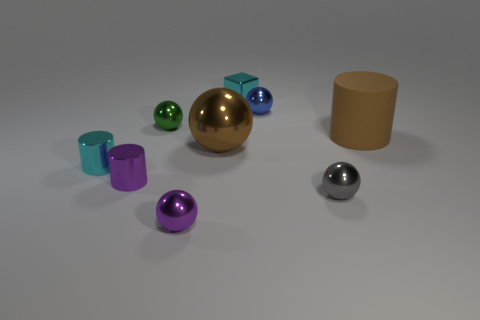Subtract all purple balls. How many balls are left? 4 Subtract 1 spheres. How many spheres are left? 4 Subtract all purple balls. How many balls are left? 4 Subtract all yellow balls. Subtract all blue cylinders. How many balls are left? 5 Add 1 tiny green cylinders. How many objects exist? 10 Subtract all blocks. How many objects are left? 8 Add 6 small cyan objects. How many small cyan objects exist? 8 Subtract 1 purple cylinders. How many objects are left? 8 Subtract all brown rubber objects. Subtract all big red blocks. How many objects are left? 8 Add 4 big brown shiny things. How many big brown shiny things are left? 5 